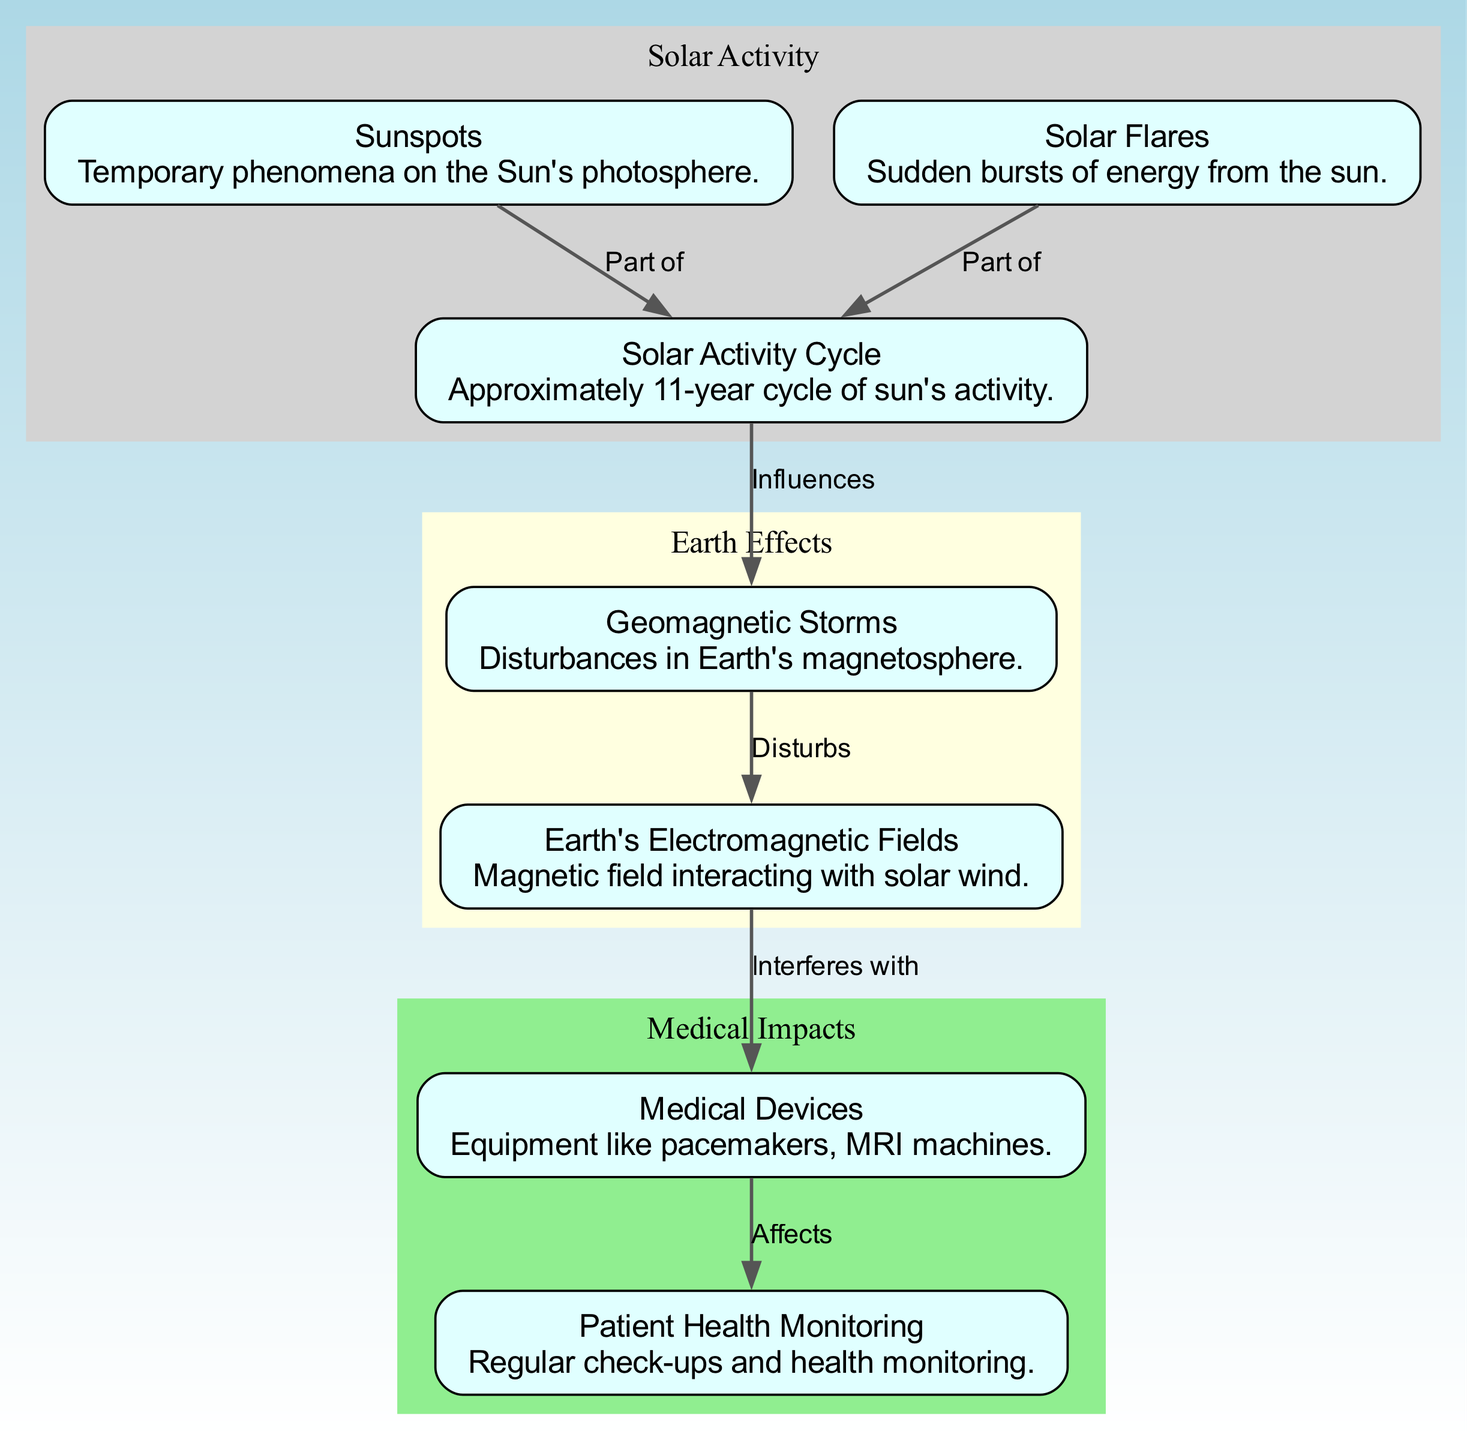What are temporary phenomena on the Sun's photosphere? The diagram labels "Sunspots" as the temporary phenomena on the Sun's photosphere. This is directly stated in the node description.
Answer: Sunspots What influences geomagnetic storms? The diagram indicates that "Solar Activity Cycle" influences "Geomagnetic Storms." This is evident from the labeled edge connecting these two nodes.
Answer: Solar Activity Cycle How many medical devices are listed in the diagram? There is only one node labeled "Medical Devices" in the diagram. Thus, the count is straightforward based on its singular presence in the visualization.
Answer: One What do Earth's electromagnetic fields interact with? According to the diagram, "Earth's Electromagnetic Fields" interact with solar wind, which is indirectly illustrated since they are affected by "Geomagnetic Storms" that are caused by solar activity.
Answer: Solar wind Which aspect affects patient health according to the diagram? The diagram shows that "Medical Devices" affect "Patient Health Monitoring." This relationship is established in the edge that connects these two nodes.
Answer: Medical Devices What part of the solar activity cycle involves solar flares? The diagram specifies that "Solar Flares" are a part of the "Solar Activity Cycle." This relationship is shown through the edge connecting these two nodes clearly labeled "Part of."
Answer: Solar Activity Cycle How do geomagnetic storms disturb Earth's electromagnetic fields? The diagram states that "Geomagnetic Storms" disturb "Earth's Electromagnetic Fields." This indicates a direct relationship where geomagnetic storms impact electromagnetic conditions on Earth.
Answer: Disturbs What do medical devices potentially interfere with? The relationship shows that "Earth's Electromagnetic Fields" interfere with "Medical Devices." Thus, this direct impact is reflected in the diagram with the connecting edge.
Answer: Medical Devices What is the approximate cycle length of solar activity? The diagram describes "Solar Activity Cycle" as having an approximate length of 11 years, which is explicitly stated in the node's description.
Answer: 11 years 